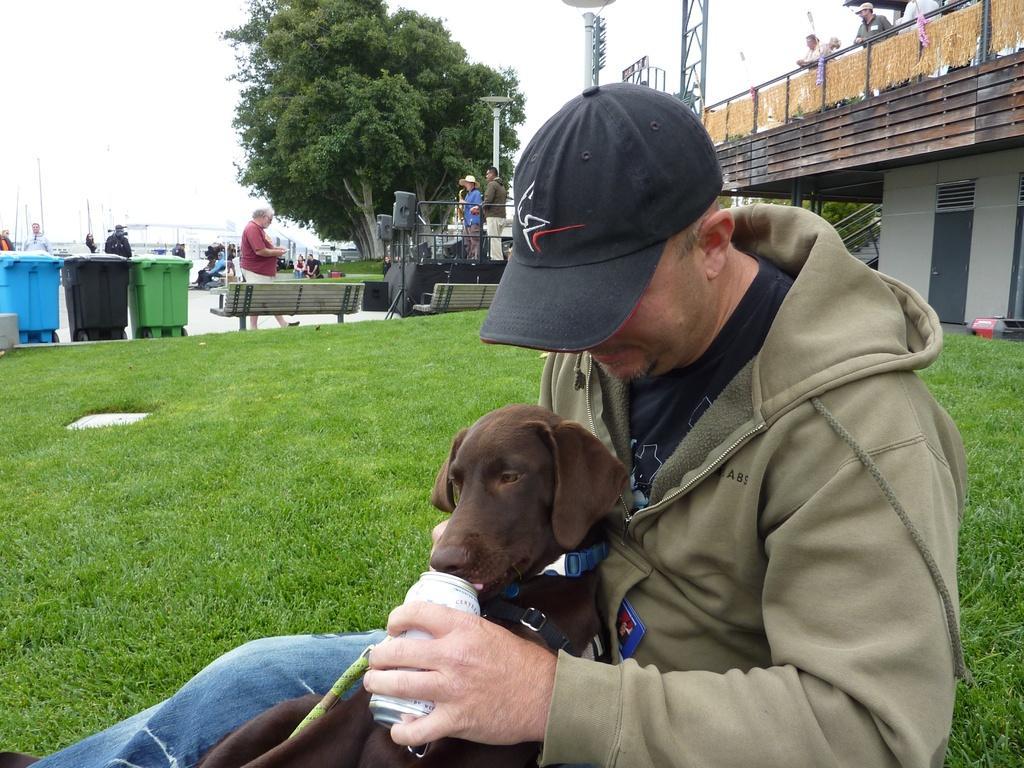How would you summarize this image in a sentence or two? On the background we can see sky, tree. This is a bridge. We can see few persons standing near to it. We can see few persons standing and walking on the road. These are trash cans. This is a grass. These are benches. We can see one man sitting on a grass and feeding a dog. He wore a cap in black colour. 